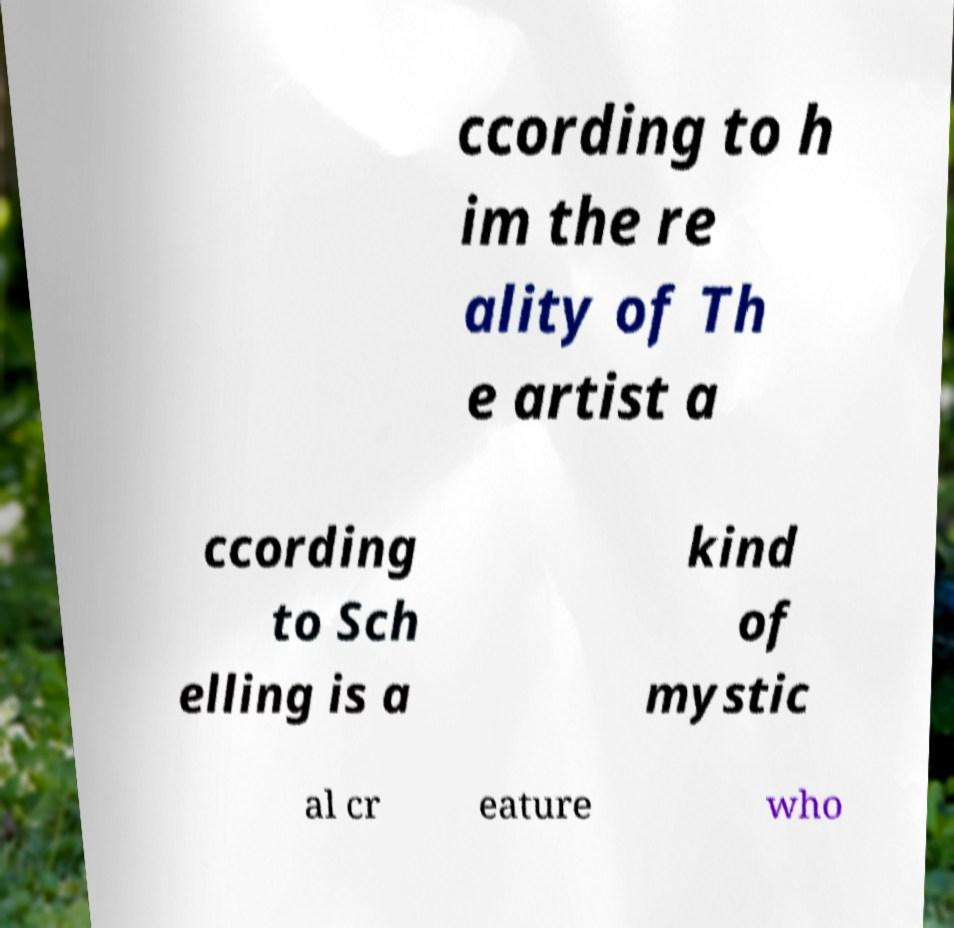There's text embedded in this image that I need extracted. Can you transcribe it verbatim? ccording to h im the re ality of Th e artist a ccording to Sch elling is a kind of mystic al cr eature who 